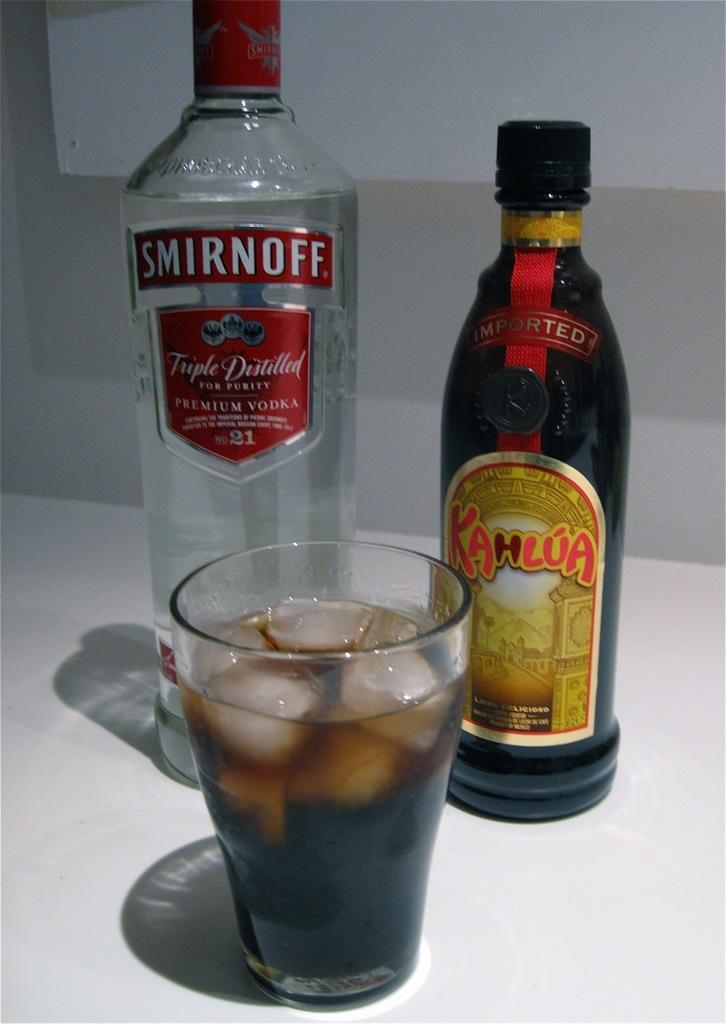<image>
Present a compact description of the photo's key features. A bottle of Smirnoff vodka and Kahlúa stand behind a glass with dark liquid and ice in it. 